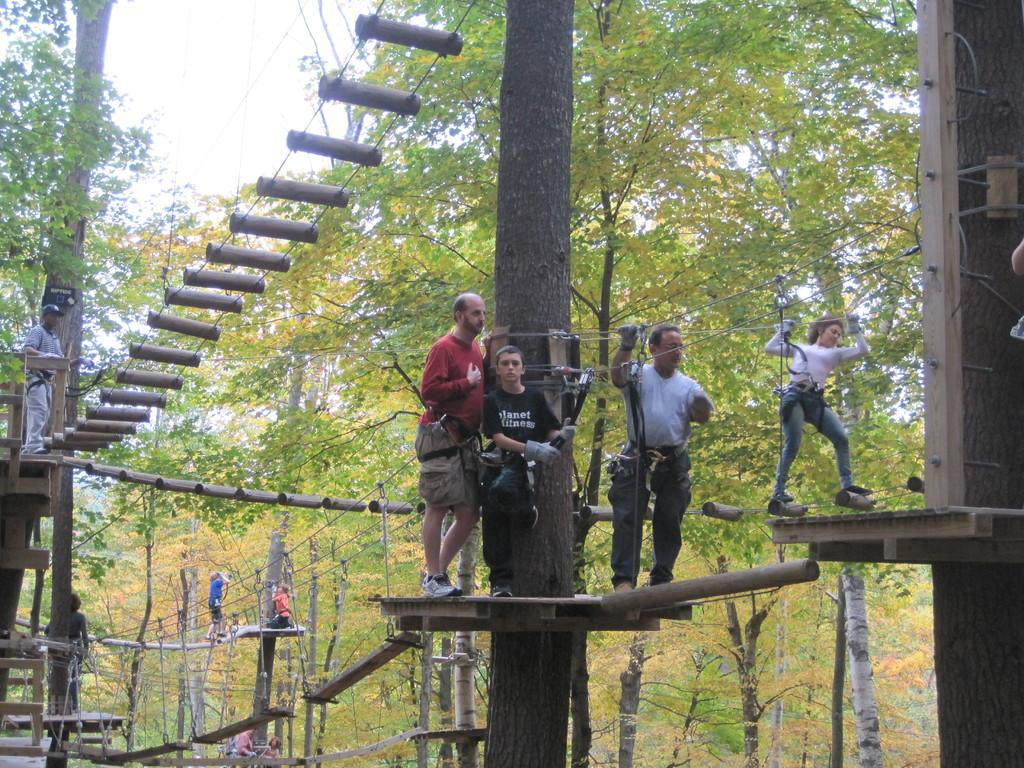What can be seen in the background of the image? The sky is visible in the background of the image. What type of natural elements are present in the image? There are trees in the image, including tree trunks. What else can be found in the image besides trees? There are objects and people visible in the image. Can you describe the woman's actions in the image? There is a woman holding ropes on the right side of the image. What type of pencil can be seen in the image? There is no pencil present in the image. How does the fog affect the visibility of the trees in the image? There is no fog present in the image, so it does not affect the visibility of the trees. 